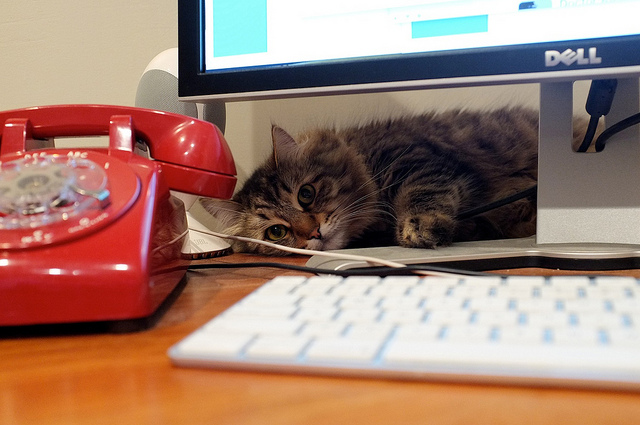Read all the text in this image. DELL 